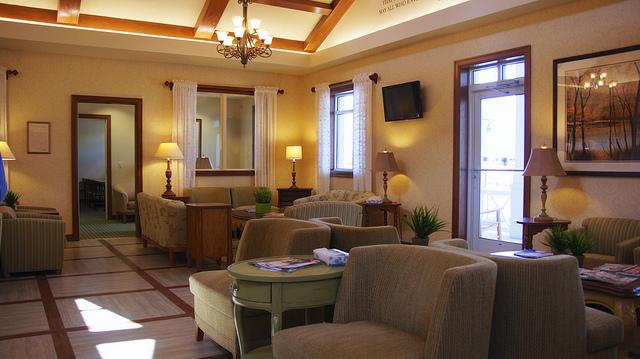What type room is this? waiting room 